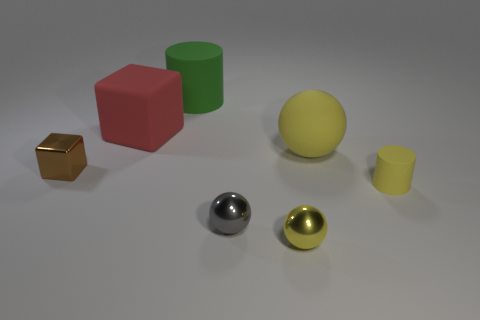There is a ball that is the same size as the gray metallic object; what is it made of?
Give a very brief answer. Metal. What number of other objects are there of the same material as the small brown block?
Your answer should be compact. 2. Are there the same number of tiny metallic cubes on the right side of the large red thing and rubber things that are behind the tiny brown cube?
Your answer should be compact. No. How many yellow things are large metal things or small cylinders?
Provide a succinct answer. 1. Is the color of the small matte thing the same as the big rubber thing that is in front of the red object?
Ensure brevity in your answer.  Yes. How many other objects are there of the same color as the matte ball?
Provide a short and direct response. 2. Is the number of small purple objects less than the number of brown cubes?
Give a very brief answer. Yes. How many things are on the left side of the small yellow shiny thing that is right of the shiny ball left of the yellow shiny object?
Provide a short and direct response. 4. What size is the cube behind the large yellow ball?
Make the answer very short. Large. Is the shape of the shiny object in front of the tiny gray thing the same as  the large red matte thing?
Ensure brevity in your answer.  No. 